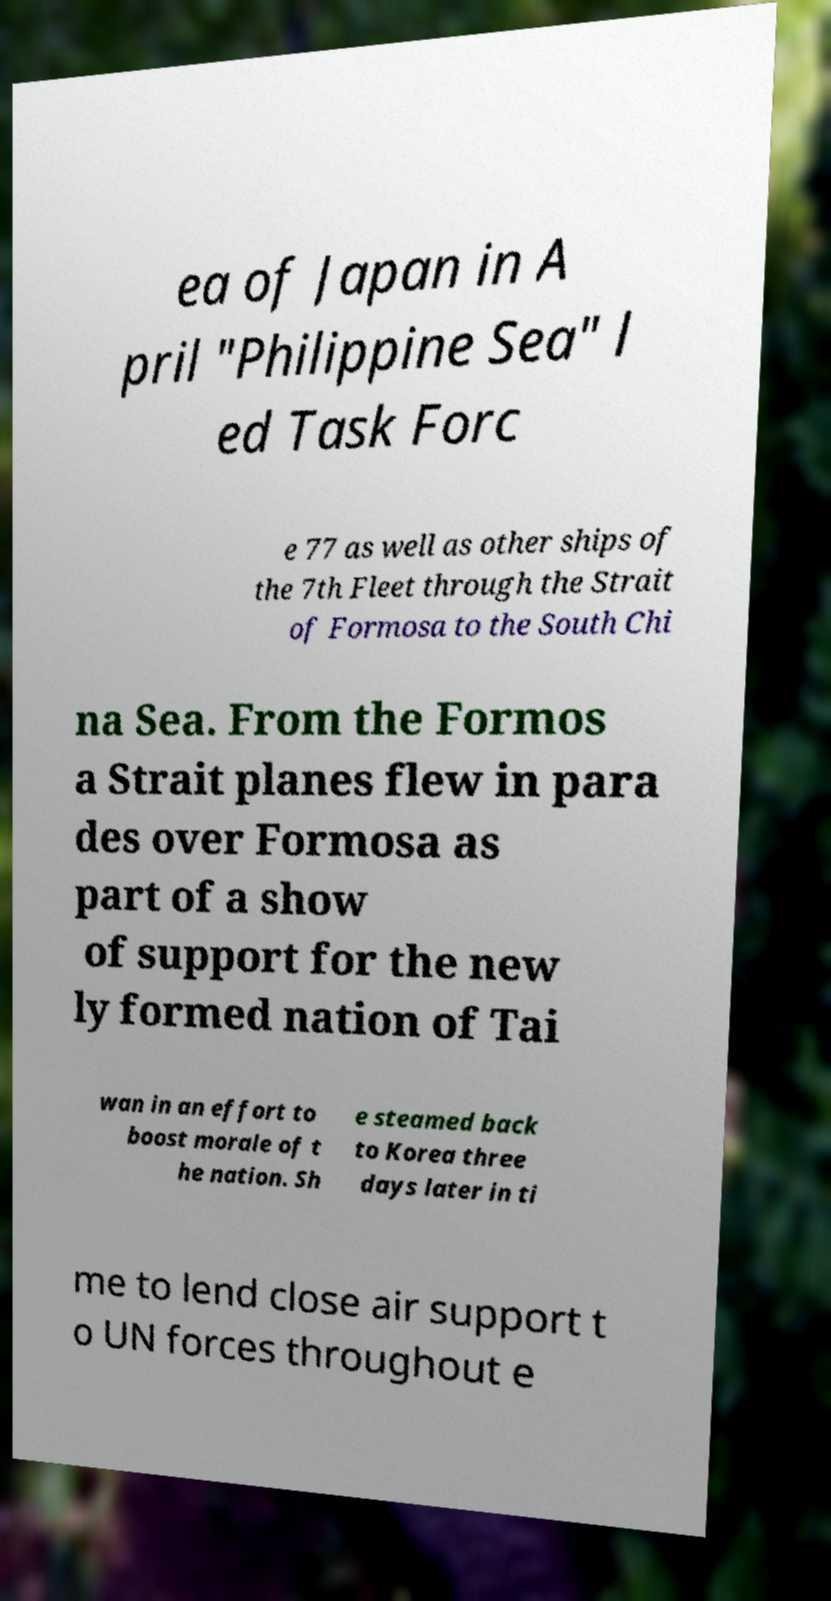What messages or text are displayed in this image? I need them in a readable, typed format. ea of Japan in A pril "Philippine Sea" l ed Task Forc e 77 as well as other ships of the 7th Fleet through the Strait of Formosa to the South Chi na Sea. From the Formos a Strait planes flew in para des over Formosa as part of a show of support for the new ly formed nation of Tai wan in an effort to boost morale of t he nation. Sh e steamed back to Korea three days later in ti me to lend close air support t o UN forces throughout e 